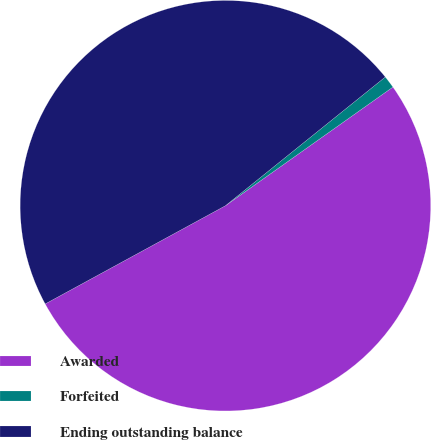Convert chart. <chart><loc_0><loc_0><loc_500><loc_500><pie_chart><fcel>Awarded<fcel>Forfeited<fcel>Ending outstanding balance<nl><fcel>51.87%<fcel>0.98%<fcel>47.15%<nl></chart> 